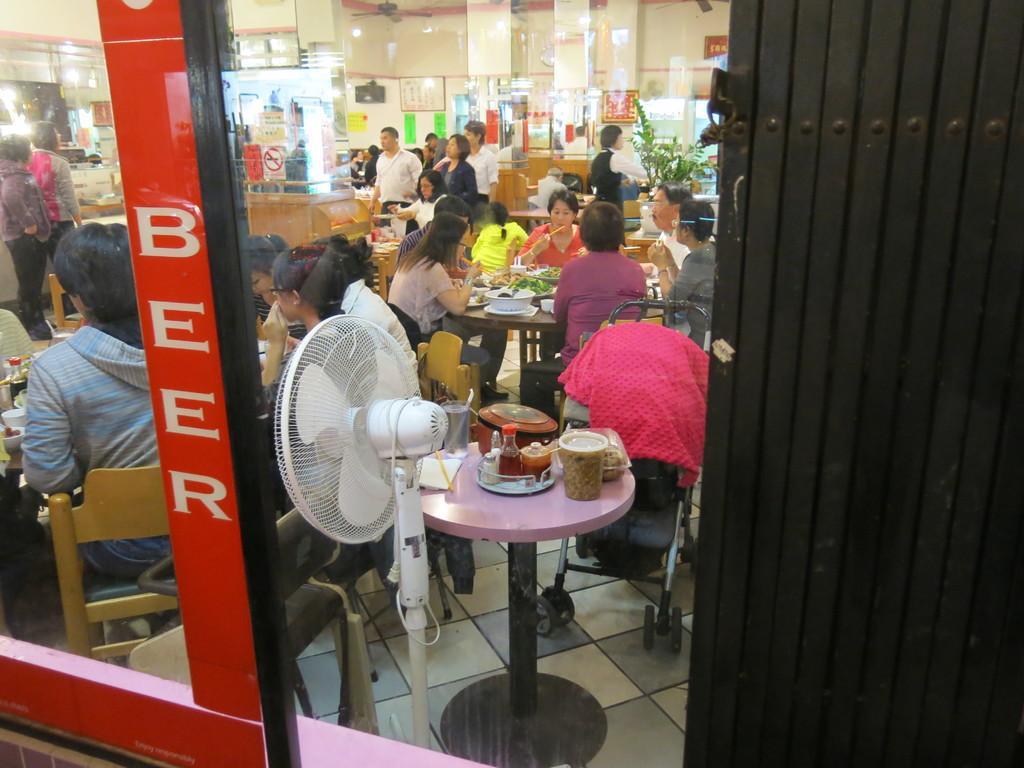In one or two sentences, can you explain what this image depicts? The picture is taken in a restaurant where number of people sitting on their chairs in front of the tables and having food and at the right corner of the picture there is one small troller and a pink colour towel on it, in front of it there is a table and food items on it and there is a fan placed towards the people and in the right corner of the picture there are two people standing and there is a big glass window present outside of the restaurant. 